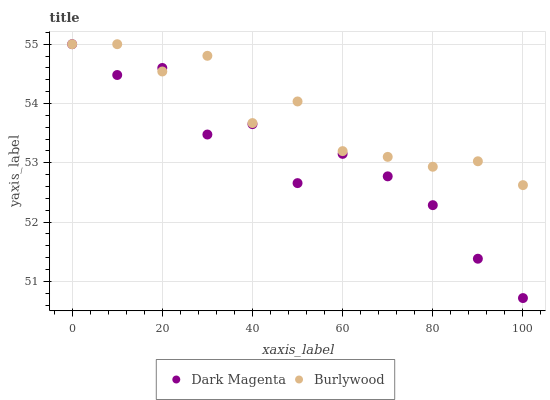Does Dark Magenta have the minimum area under the curve?
Answer yes or no. Yes. Does Burlywood have the maximum area under the curve?
Answer yes or no. Yes. Does Dark Magenta have the maximum area under the curve?
Answer yes or no. No. Is Burlywood the smoothest?
Answer yes or no. Yes. Is Dark Magenta the roughest?
Answer yes or no. Yes. Is Dark Magenta the smoothest?
Answer yes or no. No. Does Dark Magenta have the lowest value?
Answer yes or no. Yes. Does Dark Magenta have the highest value?
Answer yes or no. Yes. Does Burlywood intersect Dark Magenta?
Answer yes or no. Yes. Is Burlywood less than Dark Magenta?
Answer yes or no. No. Is Burlywood greater than Dark Magenta?
Answer yes or no. No. 